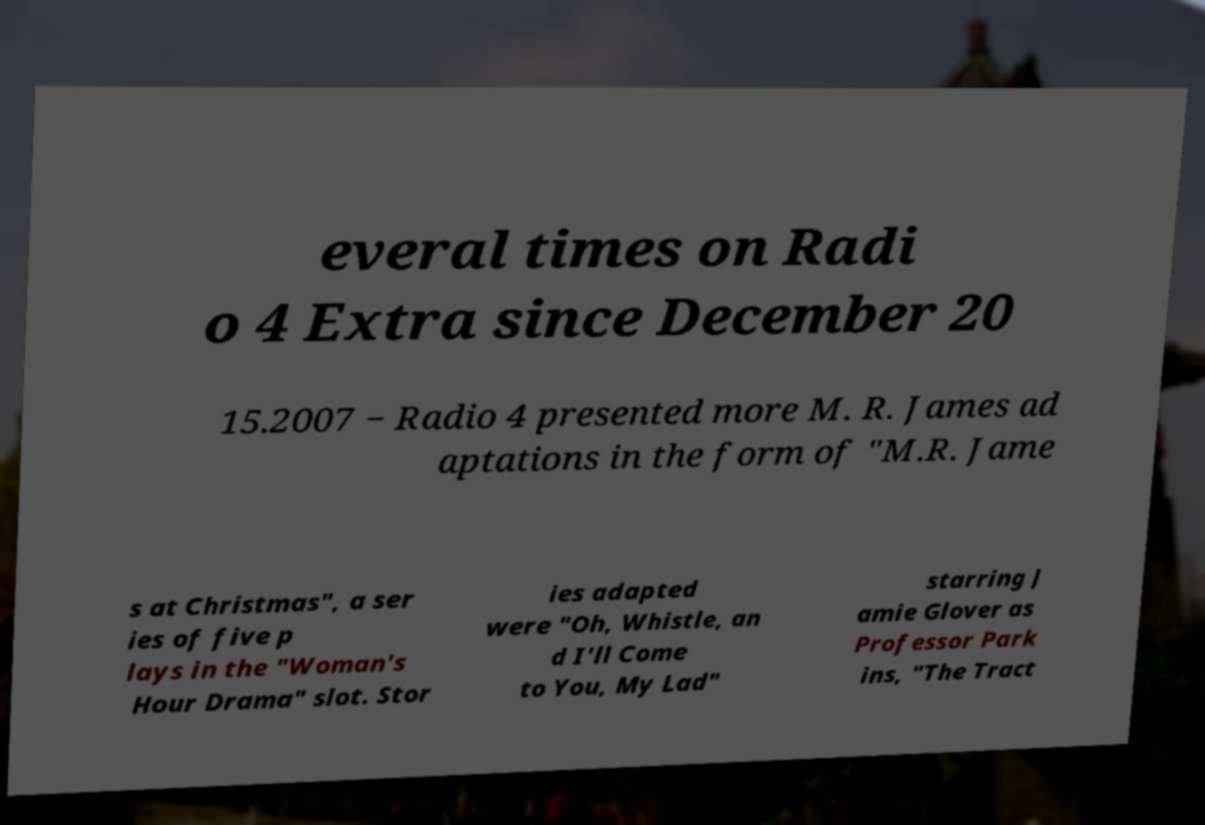What messages or text are displayed in this image? I need them in a readable, typed format. everal times on Radi o 4 Extra since December 20 15.2007 − Radio 4 presented more M. R. James ad aptations in the form of "M.R. Jame s at Christmas", a ser ies of five p lays in the "Woman's Hour Drama" slot. Stor ies adapted were "Oh, Whistle, an d I'll Come to You, My Lad" starring J amie Glover as Professor Park ins, "The Tract 